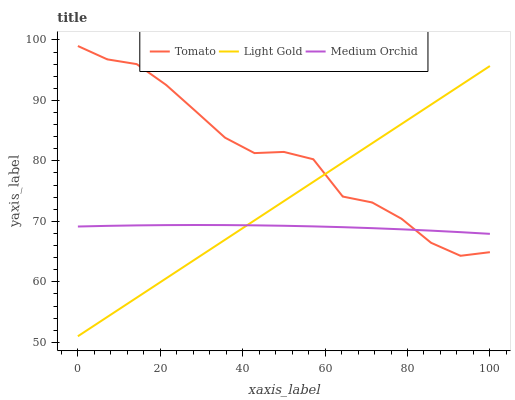Does Light Gold have the minimum area under the curve?
Answer yes or no. No. Does Light Gold have the maximum area under the curve?
Answer yes or no. No. Is Medium Orchid the smoothest?
Answer yes or no. No. Is Medium Orchid the roughest?
Answer yes or no. No. Does Medium Orchid have the lowest value?
Answer yes or no. No. Does Light Gold have the highest value?
Answer yes or no. No. 